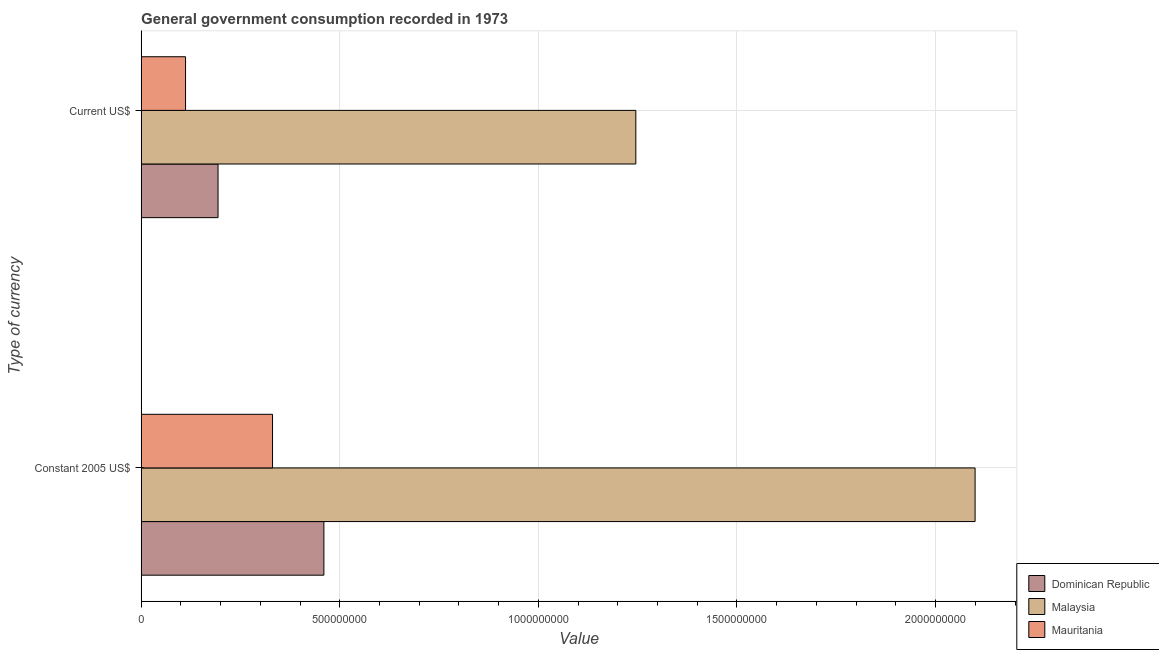Are the number of bars per tick equal to the number of legend labels?
Provide a succinct answer. Yes. Are the number of bars on each tick of the Y-axis equal?
Ensure brevity in your answer.  Yes. How many bars are there on the 2nd tick from the top?
Your response must be concise. 3. What is the label of the 1st group of bars from the top?
Offer a terse response. Current US$. What is the value consumed in constant 2005 us$ in Dominican Republic?
Your answer should be compact. 4.60e+08. Across all countries, what is the maximum value consumed in constant 2005 us$?
Your answer should be compact. 2.10e+09. Across all countries, what is the minimum value consumed in current us$?
Make the answer very short. 1.12e+08. In which country was the value consumed in constant 2005 us$ maximum?
Offer a very short reply. Malaysia. In which country was the value consumed in current us$ minimum?
Provide a succinct answer. Mauritania. What is the total value consumed in current us$ in the graph?
Give a very brief answer. 1.55e+09. What is the difference between the value consumed in current us$ in Malaysia and that in Dominican Republic?
Your answer should be very brief. 1.05e+09. What is the difference between the value consumed in current us$ in Malaysia and the value consumed in constant 2005 us$ in Dominican Republic?
Make the answer very short. 7.85e+08. What is the average value consumed in constant 2005 us$ per country?
Provide a succinct answer. 9.63e+08. What is the difference between the value consumed in constant 2005 us$ and value consumed in current us$ in Dominican Republic?
Your response must be concise. 2.66e+08. In how many countries, is the value consumed in constant 2005 us$ greater than 900000000 ?
Your answer should be compact. 1. What is the ratio of the value consumed in current us$ in Mauritania to that in Dominican Republic?
Provide a succinct answer. 0.58. In how many countries, is the value consumed in constant 2005 us$ greater than the average value consumed in constant 2005 us$ taken over all countries?
Your response must be concise. 1. What does the 3rd bar from the top in Constant 2005 US$ represents?
Keep it short and to the point. Dominican Republic. What does the 2nd bar from the bottom in Current US$ represents?
Your answer should be compact. Malaysia. How many bars are there?
Provide a short and direct response. 6. Are all the bars in the graph horizontal?
Your answer should be compact. Yes. Does the graph contain any zero values?
Ensure brevity in your answer.  No. Where does the legend appear in the graph?
Your answer should be compact. Bottom right. How are the legend labels stacked?
Give a very brief answer. Vertical. What is the title of the graph?
Offer a very short reply. General government consumption recorded in 1973. Does "Cote d'Ivoire" appear as one of the legend labels in the graph?
Your response must be concise. No. What is the label or title of the X-axis?
Your response must be concise. Value. What is the label or title of the Y-axis?
Give a very brief answer. Type of currency. What is the Value in Dominican Republic in Constant 2005 US$?
Keep it short and to the point. 4.60e+08. What is the Value of Malaysia in Constant 2005 US$?
Your answer should be very brief. 2.10e+09. What is the Value of Mauritania in Constant 2005 US$?
Your answer should be compact. 3.31e+08. What is the Value in Dominican Republic in Current US$?
Your answer should be very brief. 1.94e+08. What is the Value of Malaysia in Current US$?
Offer a very short reply. 1.25e+09. What is the Value of Mauritania in Current US$?
Provide a short and direct response. 1.12e+08. Across all Type of currency, what is the maximum Value in Dominican Republic?
Offer a terse response. 4.60e+08. Across all Type of currency, what is the maximum Value of Malaysia?
Make the answer very short. 2.10e+09. Across all Type of currency, what is the maximum Value in Mauritania?
Offer a very short reply. 3.31e+08. Across all Type of currency, what is the minimum Value of Dominican Republic?
Keep it short and to the point. 1.94e+08. Across all Type of currency, what is the minimum Value in Malaysia?
Ensure brevity in your answer.  1.25e+09. Across all Type of currency, what is the minimum Value of Mauritania?
Provide a short and direct response. 1.12e+08. What is the total Value of Dominican Republic in the graph?
Offer a terse response. 6.54e+08. What is the total Value of Malaysia in the graph?
Keep it short and to the point. 3.34e+09. What is the total Value of Mauritania in the graph?
Provide a succinct answer. 4.43e+08. What is the difference between the Value of Dominican Republic in Constant 2005 US$ and that in Current US$?
Offer a very short reply. 2.66e+08. What is the difference between the Value of Malaysia in Constant 2005 US$ and that in Current US$?
Keep it short and to the point. 8.54e+08. What is the difference between the Value of Mauritania in Constant 2005 US$ and that in Current US$?
Your answer should be compact. 2.19e+08. What is the difference between the Value of Dominican Republic in Constant 2005 US$ and the Value of Malaysia in Current US$?
Offer a terse response. -7.85e+08. What is the difference between the Value in Dominican Republic in Constant 2005 US$ and the Value in Mauritania in Current US$?
Give a very brief answer. 3.48e+08. What is the difference between the Value of Malaysia in Constant 2005 US$ and the Value of Mauritania in Current US$?
Your response must be concise. 1.99e+09. What is the average Value in Dominican Republic per Type of currency?
Provide a short and direct response. 3.27e+08. What is the average Value of Malaysia per Type of currency?
Provide a succinct answer. 1.67e+09. What is the average Value in Mauritania per Type of currency?
Offer a terse response. 2.21e+08. What is the difference between the Value of Dominican Republic and Value of Malaysia in Constant 2005 US$?
Your answer should be very brief. -1.64e+09. What is the difference between the Value in Dominican Republic and Value in Mauritania in Constant 2005 US$?
Your answer should be very brief. 1.29e+08. What is the difference between the Value in Malaysia and Value in Mauritania in Constant 2005 US$?
Provide a succinct answer. 1.77e+09. What is the difference between the Value of Dominican Republic and Value of Malaysia in Current US$?
Make the answer very short. -1.05e+09. What is the difference between the Value of Dominican Republic and Value of Mauritania in Current US$?
Your answer should be compact. 8.18e+07. What is the difference between the Value of Malaysia and Value of Mauritania in Current US$?
Your answer should be compact. 1.13e+09. What is the ratio of the Value of Dominican Republic in Constant 2005 US$ to that in Current US$?
Keep it short and to the point. 2.38. What is the ratio of the Value in Malaysia in Constant 2005 US$ to that in Current US$?
Give a very brief answer. 1.69. What is the ratio of the Value of Mauritania in Constant 2005 US$ to that in Current US$?
Your answer should be very brief. 2.96. What is the difference between the highest and the second highest Value of Dominican Republic?
Make the answer very short. 2.66e+08. What is the difference between the highest and the second highest Value in Malaysia?
Keep it short and to the point. 8.54e+08. What is the difference between the highest and the second highest Value of Mauritania?
Offer a terse response. 2.19e+08. What is the difference between the highest and the lowest Value of Dominican Republic?
Your answer should be compact. 2.66e+08. What is the difference between the highest and the lowest Value in Malaysia?
Your answer should be very brief. 8.54e+08. What is the difference between the highest and the lowest Value of Mauritania?
Your response must be concise. 2.19e+08. 